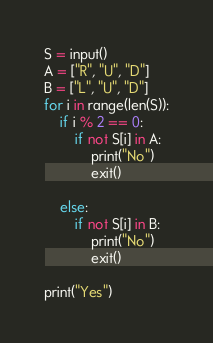Convert code to text. <code><loc_0><loc_0><loc_500><loc_500><_Python_>S = input()
A = ["R", "U", "D"]
B = ["L", "U", "D"]
for i in range(len(S)):
    if i % 2 == 0:
        if not S[i] in A:
            print("No")
            exit()

    else:
        if not S[i] in B:
            print("No")
            exit()

print("Yes")</code> 